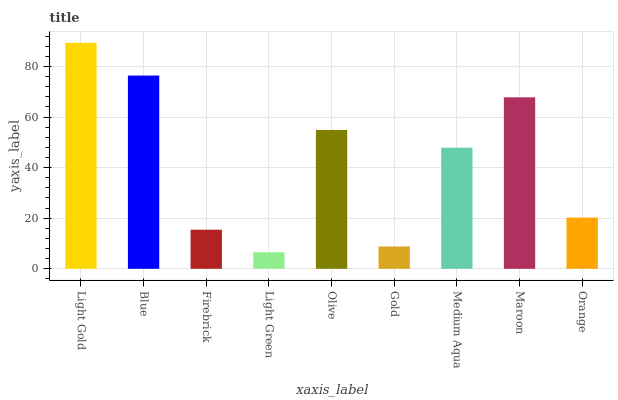Is Light Green the minimum?
Answer yes or no. Yes. Is Light Gold the maximum?
Answer yes or no. Yes. Is Blue the minimum?
Answer yes or no. No. Is Blue the maximum?
Answer yes or no. No. Is Light Gold greater than Blue?
Answer yes or no. Yes. Is Blue less than Light Gold?
Answer yes or no. Yes. Is Blue greater than Light Gold?
Answer yes or no. No. Is Light Gold less than Blue?
Answer yes or no. No. Is Medium Aqua the high median?
Answer yes or no. Yes. Is Medium Aqua the low median?
Answer yes or no. Yes. Is Firebrick the high median?
Answer yes or no. No. Is Olive the low median?
Answer yes or no. No. 